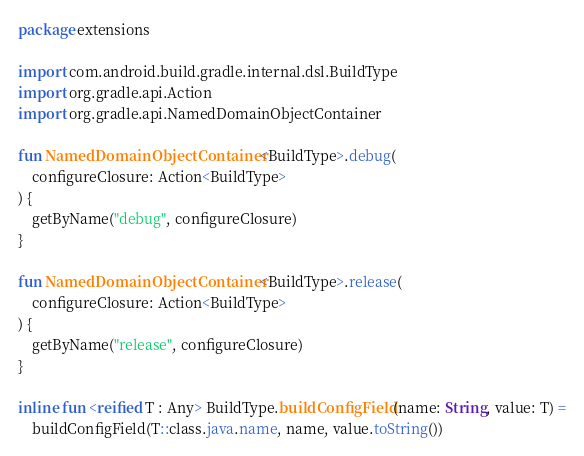<code> <loc_0><loc_0><loc_500><loc_500><_Kotlin_>package extensions

import com.android.build.gradle.internal.dsl.BuildType
import org.gradle.api.Action
import org.gradle.api.NamedDomainObjectContainer

fun NamedDomainObjectContainer<BuildType>.debug(
    configureClosure: Action<BuildType>
) {
    getByName("debug", configureClosure)
}

fun NamedDomainObjectContainer<BuildType>.release(
    configureClosure: Action<BuildType>
) {
    getByName("release", configureClosure)
}

inline fun <reified T : Any> BuildType.buildConfigField(name: String, value: T) =
    buildConfigField(T::class.java.name, name, value.toString())
</code> 